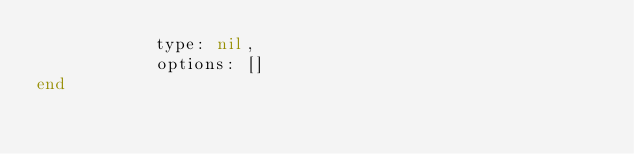<code> <loc_0><loc_0><loc_500><loc_500><_Elixir_>            type: nil,
            options: []
end
</code> 